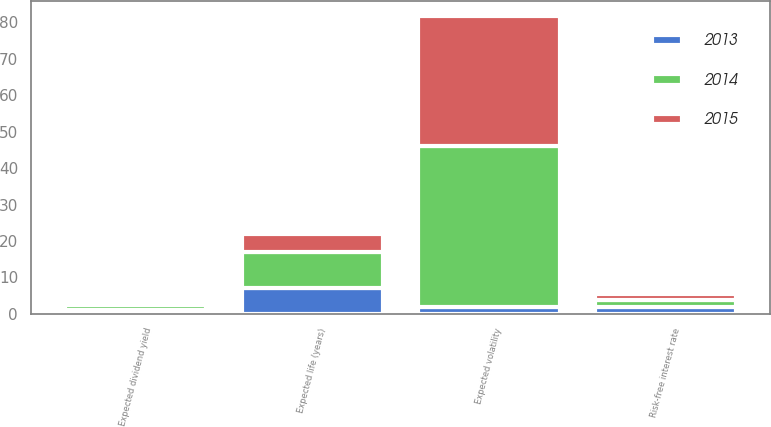<chart> <loc_0><loc_0><loc_500><loc_500><stacked_bar_chart><ecel><fcel>Expected life (years)<fcel>Risk-free interest rate<fcel>Expected volatility<fcel>Expected dividend yield<nl><fcel>2013<fcel>7<fcel>1.9<fcel>1.9<fcel>1.1<nl><fcel>2015<fcel>5<fcel>1.7<fcel>35.5<fcel>1<nl><fcel>2014<fcel>9.9<fcel>1.9<fcel>44.3<fcel>1.2<nl></chart> 